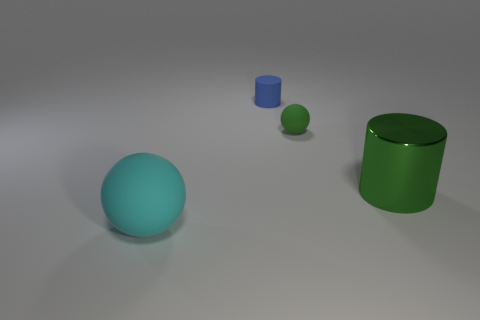Add 4 small blue shiny objects. How many objects exist? 8 Subtract 1 green spheres. How many objects are left? 3 Subtract all green shiny cylinders. Subtract all green spheres. How many objects are left? 2 Add 2 cyan rubber things. How many cyan rubber things are left? 3 Add 4 big red cylinders. How many big red cylinders exist? 4 